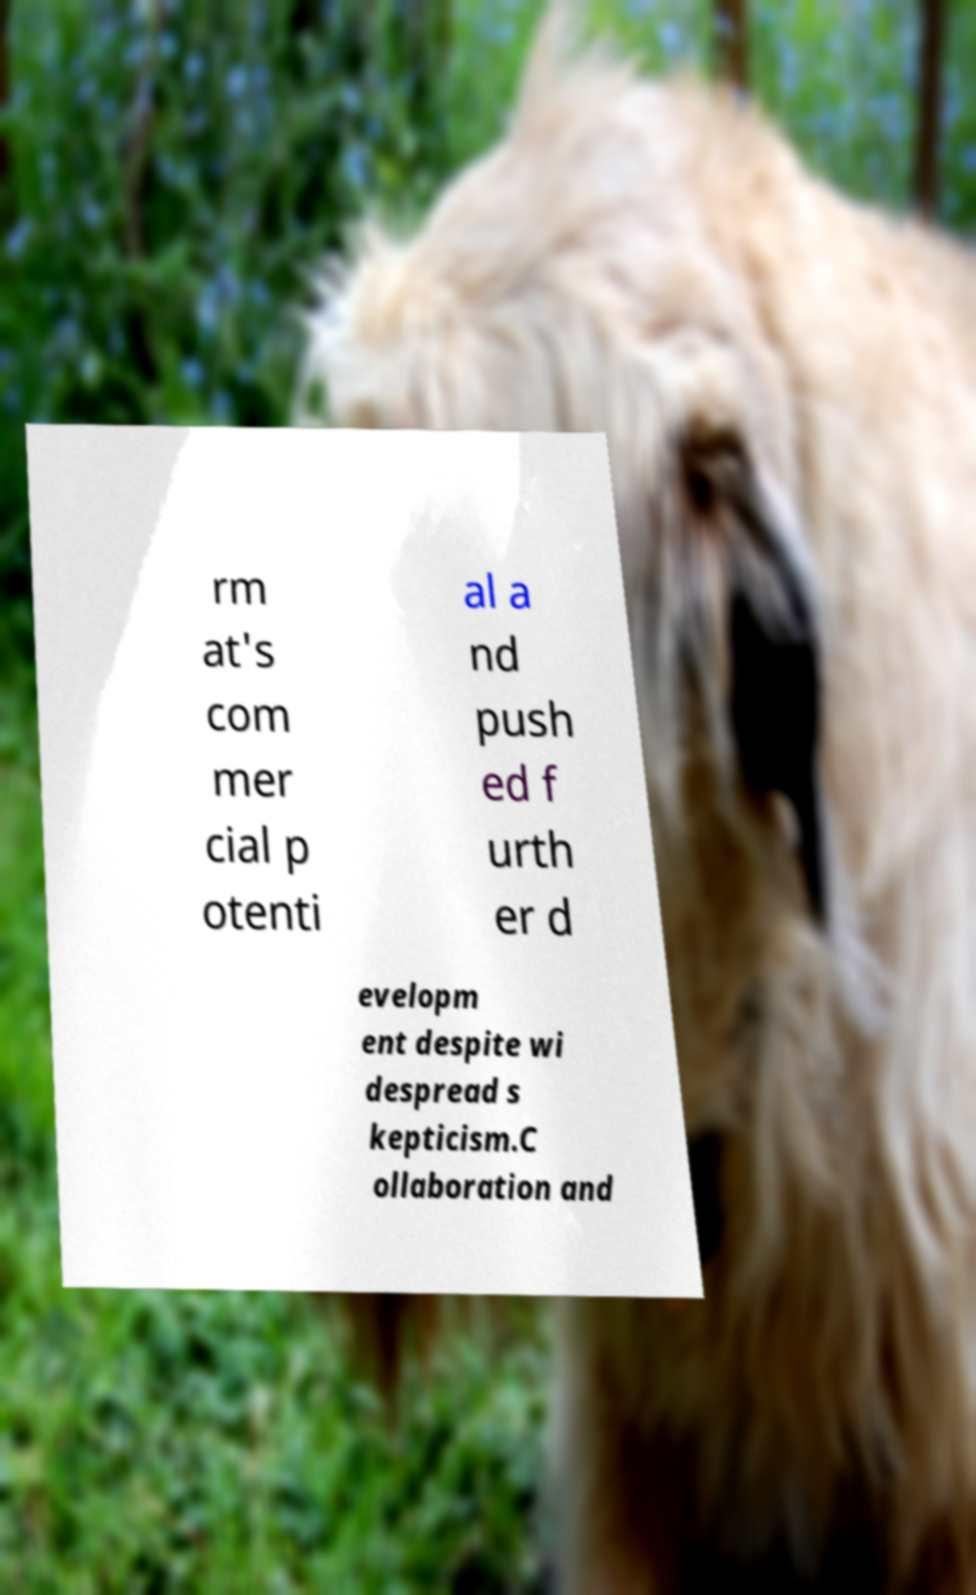Could you extract and type out the text from this image? rm at's com mer cial p otenti al a nd push ed f urth er d evelopm ent despite wi despread s kepticism.C ollaboration and 